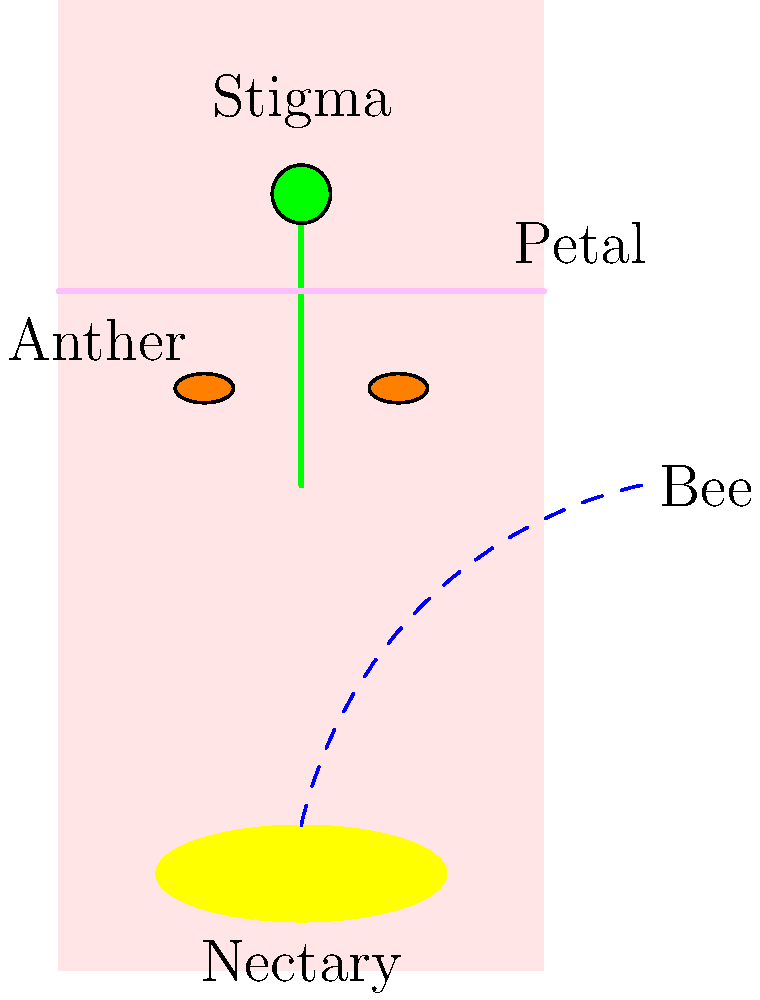In the cross-section of this flower, which feature is strategically positioned to maximize nectar accessibility for bees while ensuring pollen transfer? To answer this question, let's analyze the flower's structure step-by-step:

1. Nectary position: The nectary, which produces nectar, is located at the base of the flower. This is typical in many flowers to attract pollinators.

2. Anther position: The anthers, which produce pollen, are positioned higher up in the flower, near the middle.

3. Stigma position: The stigma, which receives pollen, is located at the top of the flower.

4. Petal arrangement: The petals are arranged to guide the bee towards the center of the flower.

5. Bee path: The dashed blue line shows the typical path a bee would take to reach the nectar.

The key to maximizing nectar accessibility while ensuring pollen transfer lies in the relative positions of these structures. As the bee moves towards the nectary, it must pass by the anthers, picking up pollen. When it visits another flower, it will likely brush against the stigma, depositing pollen.

The feature that best fits this description is the anther. Its position between the entrance of the flower and the nectary ensures that bees must come into contact with it while seeking nectar, thus maximizing the chance of pollen transfer.
Answer: Anther 